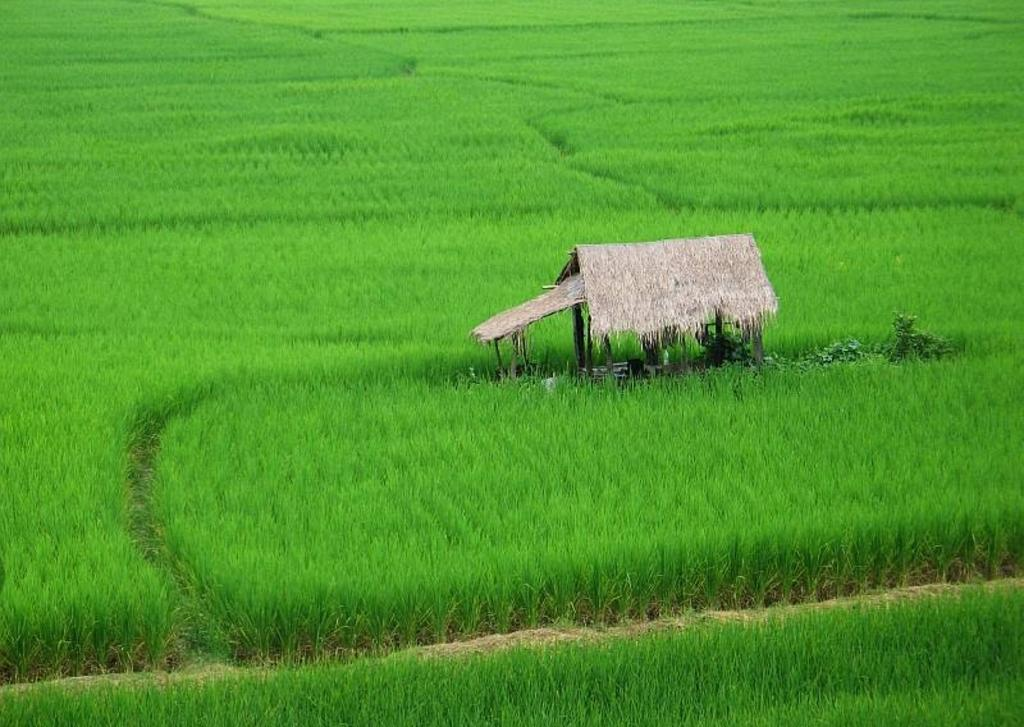What is the main subject in the image? There is a crop in the image. Is there any structure visible in the image? Yes, there is a hut in the middle of the image. What type of string is being used to hold the kettle in the image? There is no kettle present in the image, so there is no string being used to hold it. 